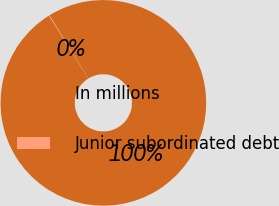<chart> <loc_0><loc_0><loc_500><loc_500><pie_chart><fcel>In millions<fcel>Junior subordinated debt<nl><fcel>99.93%<fcel>0.07%<nl></chart> 